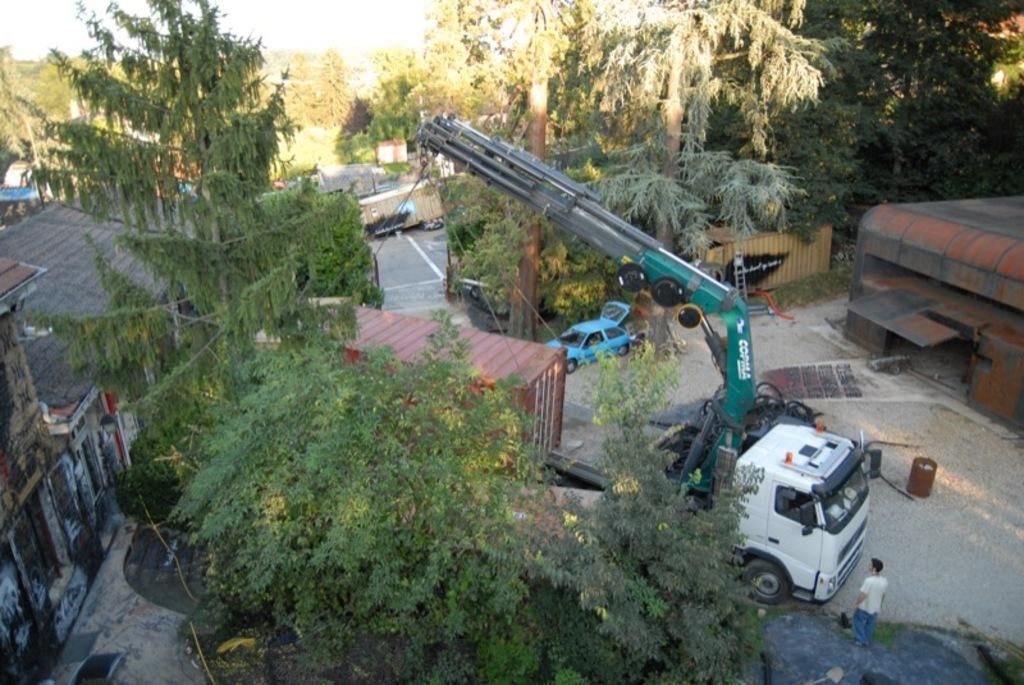What is the person in the image holding? The person is holding a guitar. Is there any other equipment related to music in the image? Yes, there is a microphone on a stand in the image. Can you describe the background of the image? The background of the image is not specified in the provided facts. What type of vessel can be seen sailing in the background of the image? There is no vessel present in the image, as it features a person holding a guitar and a microphone on a stand. 